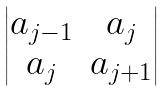Convert formula to latex. <formula><loc_0><loc_0><loc_500><loc_500>\begin{vmatrix} a _ { j - 1 } & a _ { j } \\ a _ { j } & a _ { j + 1 } \end{vmatrix}</formula> 